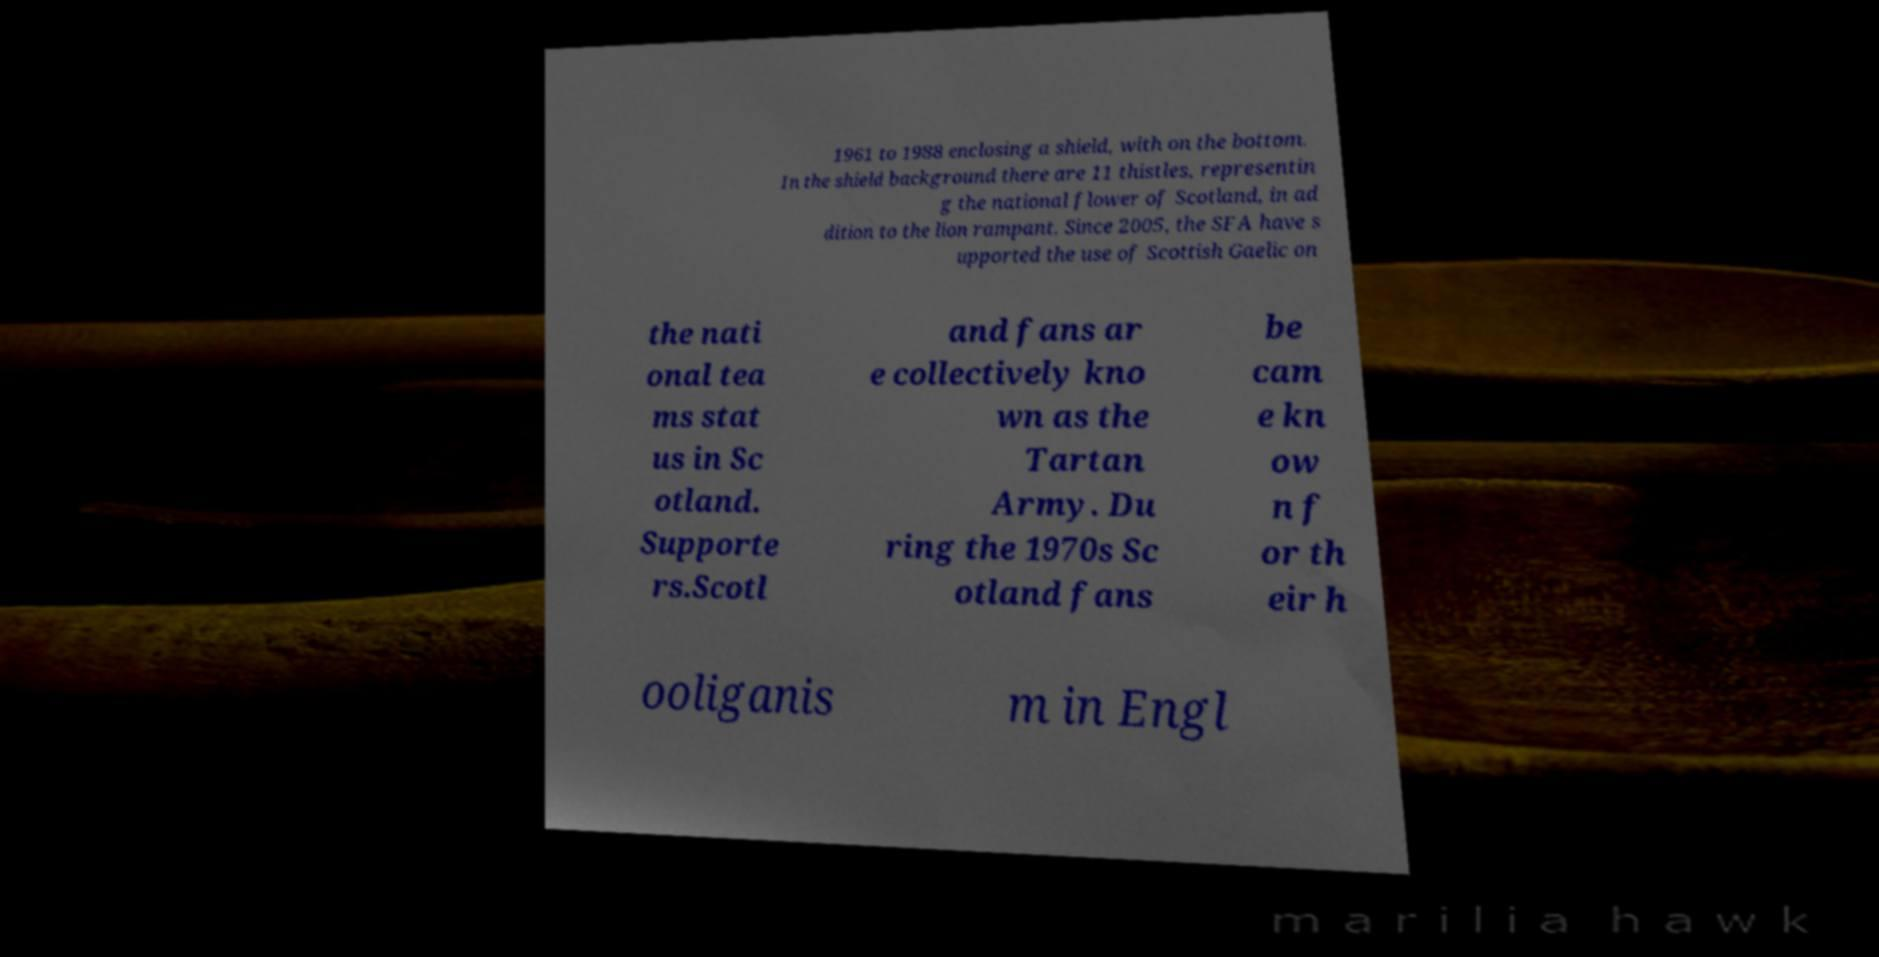Please identify and transcribe the text found in this image. 1961 to 1988 enclosing a shield, with on the bottom. In the shield background there are 11 thistles, representin g the national flower of Scotland, in ad dition to the lion rampant. Since 2005, the SFA have s upported the use of Scottish Gaelic on the nati onal tea ms stat us in Sc otland. Supporte rs.Scotl and fans ar e collectively kno wn as the Tartan Army. Du ring the 1970s Sc otland fans be cam e kn ow n f or th eir h ooliganis m in Engl 